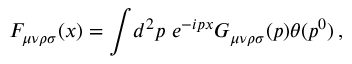<formula> <loc_0><loc_0><loc_500><loc_500>F _ { \mu \nu \rho \sigma } ( x ) = \int \, d ^ { 2 } p \ e ^ { - i p x } G _ { \mu \nu \rho \sigma } ( p ) \theta ( p ^ { 0 } ) \, ,</formula> 